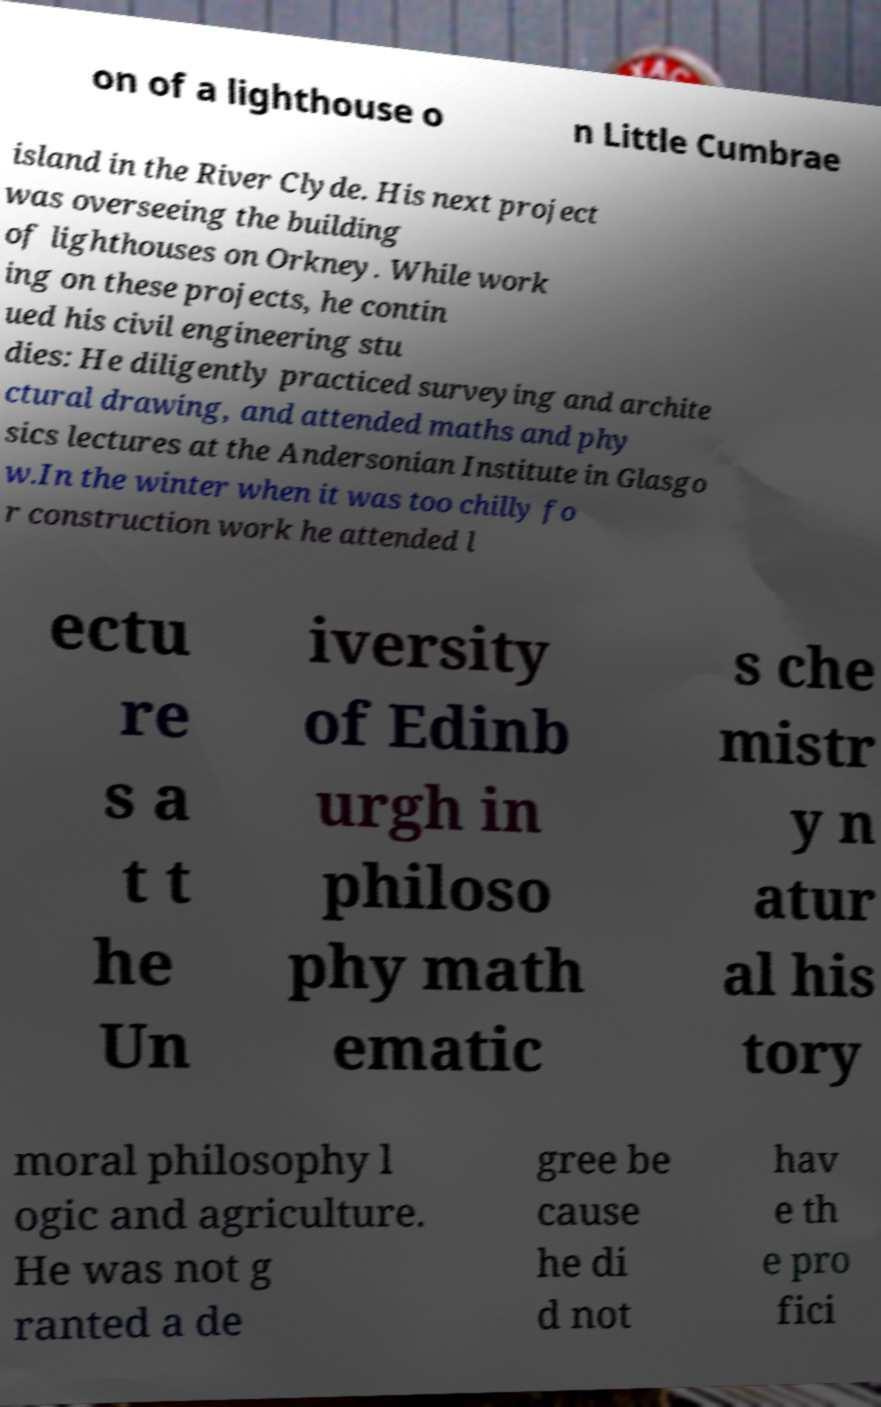Could you extract and type out the text from this image? on of a lighthouse o n Little Cumbrae island in the River Clyde. His next project was overseeing the building of lighthouses on Orkney. While work ing on these projects, he contin ued his civil engineering stu dies: He diligently practiced surveying and archite ctural drawing, and attended maths and phy sics lectures at the Andersonian Institute in Glasgo w.In the winter when it was too chilly fo r construction work he attended l ectu re s a t t he Un iversity of Edinb urgh in philoso phy math ematic s che mistr y n atur al his tory moral philosophy l ogic and agriculture. He was not g ranted a de gree be cause he di d not hav e th e pro fici 